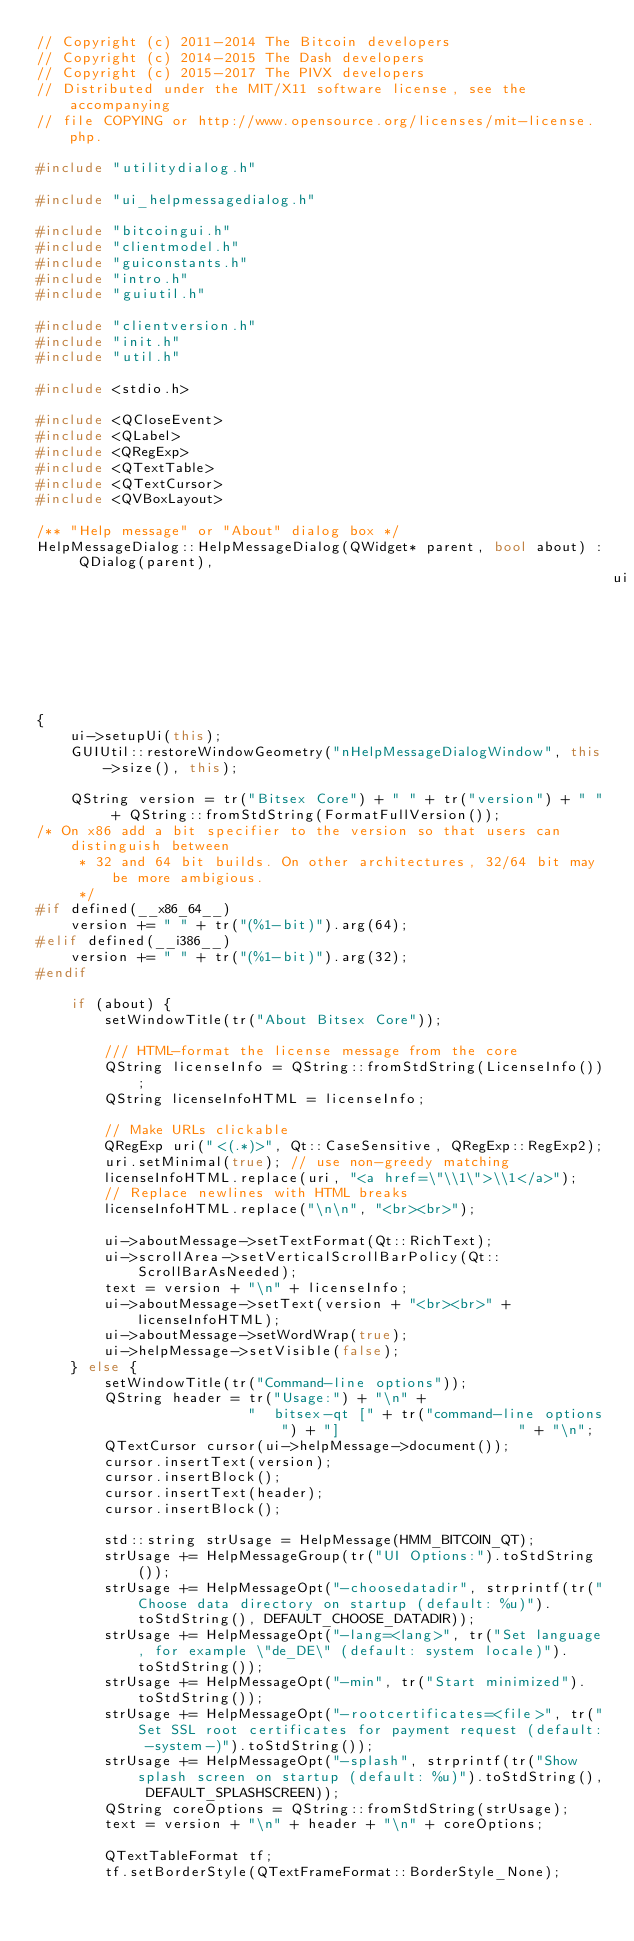<code> <loc_0><loc_0><loc_500><loc_500><_C++_>// Copyright (c) 2011-2014 The Bitcoin developers
// Copyright (c) 2014-2015 The Dash developers
// Copyright (c) 2015-2017 The PIVX developers
// Distributed under the MIT/X11 software license, see the accompanying
// file COPYING or http://www.opensource.org/licenses/mit-license.php.

#include "utilitydialog.h"

#include "ui_helpmessagedialog.h"

#include "bitcoingui.h"
#include "clientmodel.h"
#include "guiconstants.h"
#include "intro.h"
#include "guiutil.h"

#include "clientversion.h"
#include "init.h"
#include "util.h"

#include <stdio.h>

#include <QCloseEvent>
#include <QLabel>
#include <QRegExp>
#include <QTextTable>
#include <QTextCursor>
#include <QVBoxLayout>

/** "Help message" or "About" dialog box */
HelpMessageDialog::HelpMessageDialog(QWidget* parent, bool about) : QDialog(parent),
                                                                    ui(new Ui::HelpMessageDialog)
{
    ui->setupUi(this);
    GUIUtil::restoreWindowGeometry("nHelpMessageDialogWindow", this->size(), this);

    QString version = tr("Bitsex Core") + " " + tr("version") + " " + QString::fromStdString(FormatFullVersion());
/* On x86 add a bit specifier to the version so that users can distinguish between
     * 32 and 64 bit builds. On other architectures, 32/64 bit may be more ambigious.
     */
#if defined(__x86_64__)
    version += " " + tr("(%1-bit)").arg(64);
#elif defined(__i386__)
    version += " " + tr("(%1-bit)").arg(32);
#endif

    if (about) {
        setWindowTitle(tr("About Bitsex Core"));

        /// HTML-format the license message from the core
        QString licenseInfo = QString::fromStdString(LicenseInfo());
        QString licenseInfoHTML = licenseInfo;

        // Make URLs clickable
        QRegExp uri("<(.*)>", Qt::CaseSensitive, QRegExp::RegExp2);
        uri.setMinimal(true); // use non-greedy matching
        licenseInfoHTML.replace(uri, "<a href=\"\\1\">\\1</a>");
        // Replace newlines with HTML breaks
        licenseInfoHTML.replace("\n\n", "<br><br>");

        ui->aboutMessage->setTextFormat(Qt::RichText);
        ui->scrollArea->setVerticalScrollBarPolicy(Qt::ScrollBarAsNeeded);
        text = version + "\n" + licenseInfo;
        ui->aboutMessage->setText(version + "<br><br>" + licenseInfoHTML);
        ui->aboutMessage->setWordWrap(true);
        ui->helpMessage->setVisible(false);
    } else {
        setWindowTitle(tr("Command-line options"));
        QString header = tr("Usage:") + "\n" +
                         "  bitsex-qt [" + tr("command-line options") + "]                     " + "\n";
        QTextCursor cursor(ui->helpMessage->document());
        cursor.insertText(version);
        cursor.insertBlock();
        cursor.insertText(header);
        cursor.insertBlock();

        std::string strUsage = HelpMessage(HMM_BITCOIN_QT);
        strUsage += HelpMessageGroup(tr("UI Options:").toStdString());
        strUsage += HelpMessageOpt("-choosedatadir", strprintf(tr("Choose data directory on startup (default: %u)").toStdString(), DEFAULT_CHOOSE_DATADIR));
        strUsage += HelpMessageOpt("-lang=<lang>", tr("Set language, for example \"de_DE\" (default: system locale)").toStdString());
        strUsage += HelpMessageOpt("-min", tr("Start minimized").toStdString());
        strUsage += HelpMessageOpt("-rootcertificates=<file>", tr("Set SSL root certificates for payment request (default: -system-)").toStdString());
        strUsage += HelpMessageOpt("-splash", strprintf(tr("Show splash screen on startup (default: %u)").toStdString(), DEFAULT_SPLASHSCREEN));
        QString coreOptions = QString::fromStdString(strUsage);
        text = version + "\n" + header + "\n" + coreOptions;

        QTextTableFormat tf;
        tf.setBorderStyle(QTextFrameFormat::BorderStyle_None);</code> 